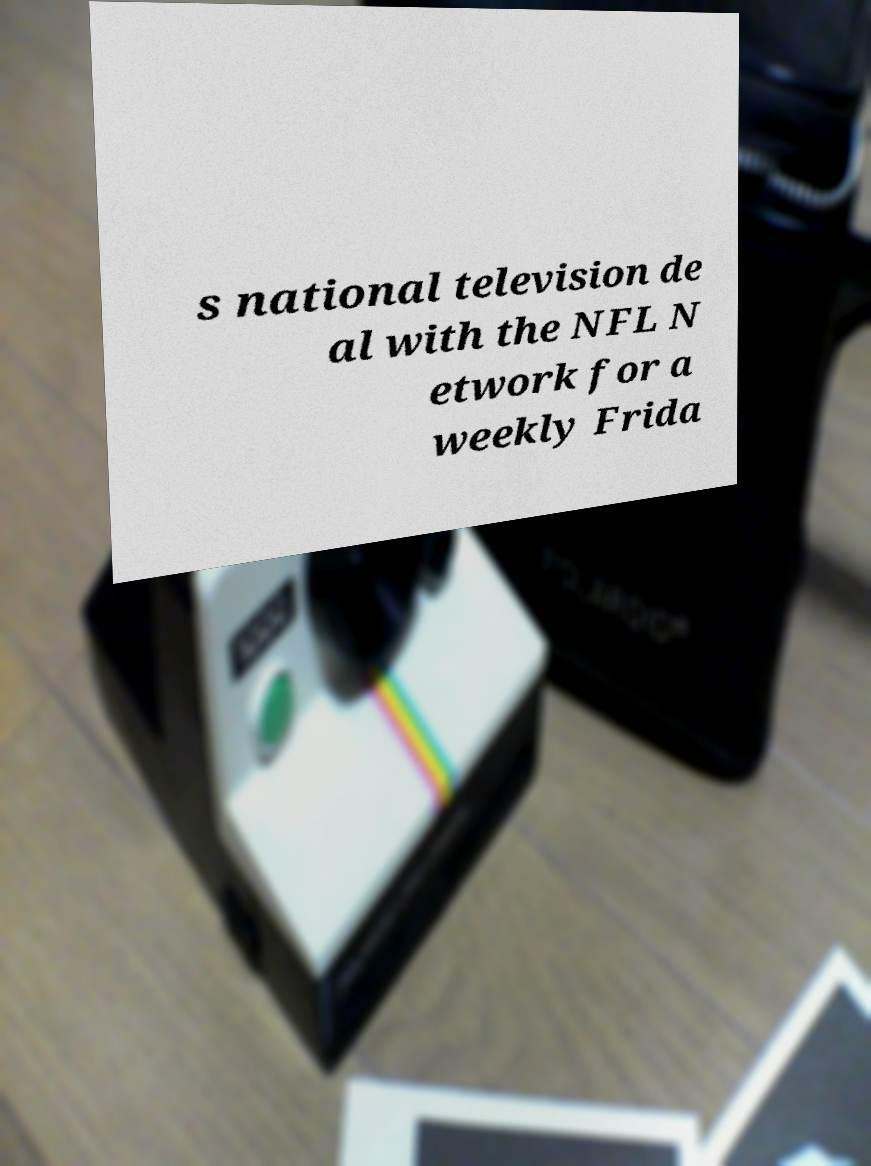Could you extract and type out the text from this image? s national television de al with the NFL N etwork for a weekly Frida 